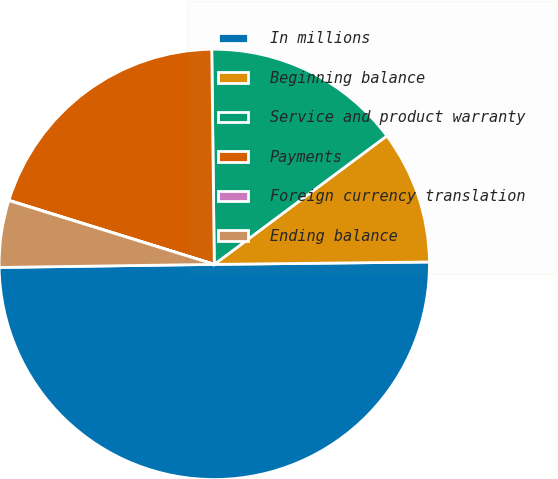Convert chart to OTSL. <chart><loc_0><loc_0><loc_500><loc_500><pie_chart><fcel>In millions<fcel>Beginning balance<fcel>Service and product warranty<fcel>Payments<fcel>Foreign currency translation<fcel>Ending balance<nl><fcel>49.95%<fcel>10.01%<fcel>15.0%<fcel>20.0%<fcel>0.02%<fcel>5.02%<nl></chart> 